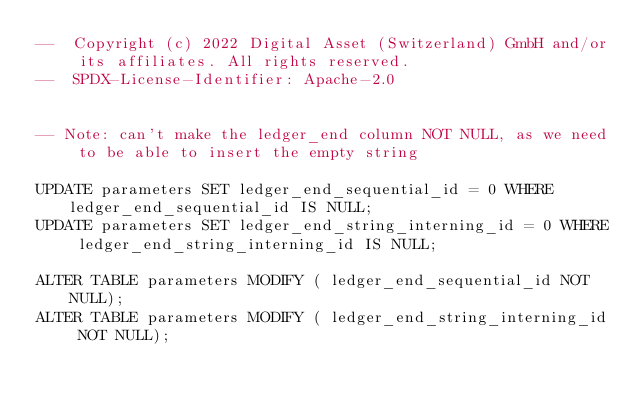Convert code to text. <code><loc_0><loc_0><loc_500><loc_500><_SQL_>--  Copyright (c) 2022 Digital Asset (Switzerland) GmbH and/or its affiliates. All rights reserved.
--  SPDX-License-Identifier: Apache-2.0


-- Note: can't make the ledger_end column NOT NULL, as we need to be able to insert the empty string

UPDATE parameters SET ledger_end_sequential_id = 0 WHERE ledger_end_sequential_id IS NULL;
UPDATE parameters SET ledger_end_string_interning_id = 0 WHERE ledger_end_string_interning_id IS NULL;

ALTER TABLE parameters MODIFY ( ledger_end_sequential_id NOT NULL);
ALTER TABLE parameters MODIFY ( ledger_end_string_interning_id NOT NULL);

</code> 